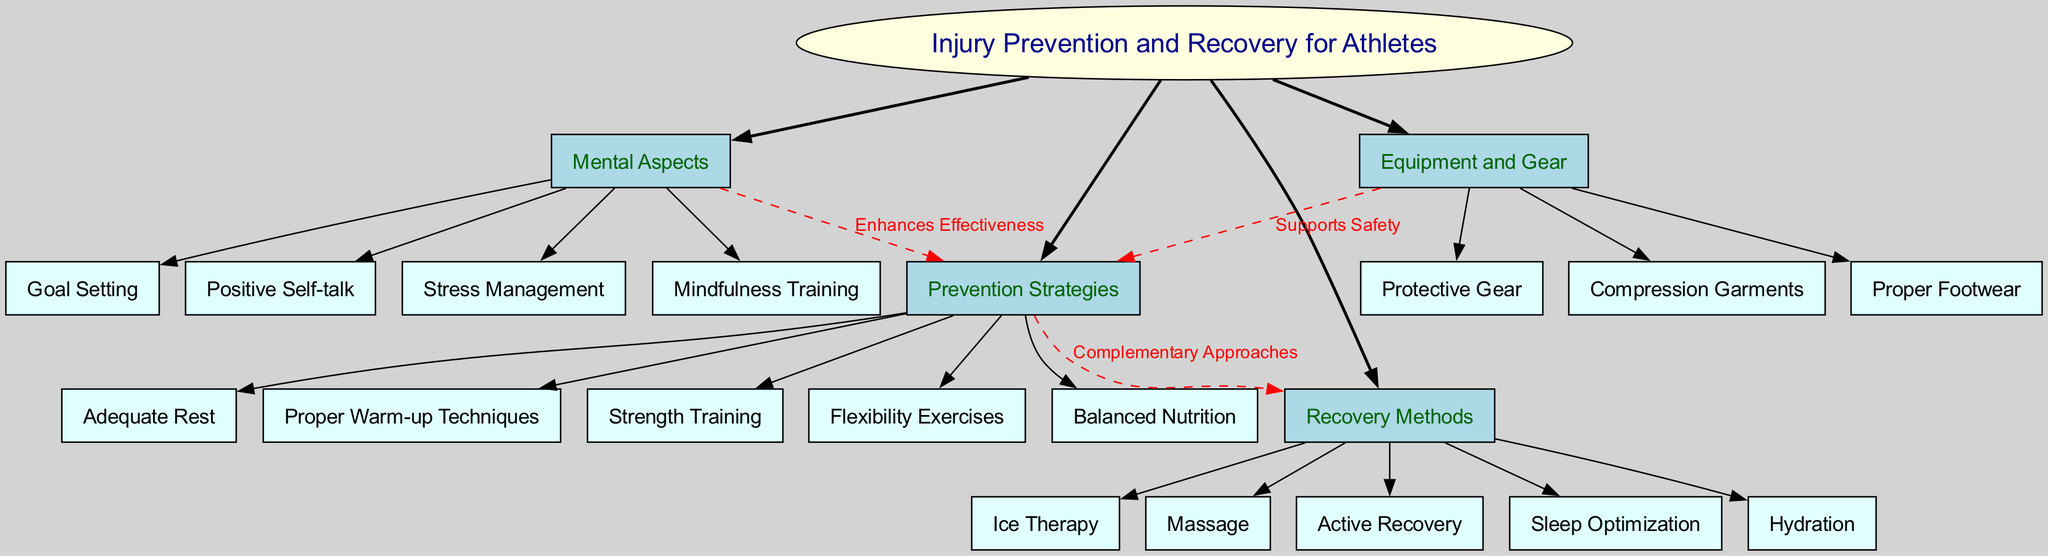What is the central concept of the diagram? The central concept is explicitly labeled in the diagram as "Injury Prevention and Recovery for Athletes," which is the main topic around which all other elements are organized.
Answer: Injury Prevention and Recovery for Athletes How many main branches are there? By reviewing the diagram, I can see that four main branches extend from the central concept: Prevention Strategies, Recovery Methods, Mental Aspects, and Equipment and Gear. That makes a total of 4 branches.
Answer: 4 What is one of the sub-branches under "Recovery Methods"? Looking under the "Recovery Methods" branch, there are several sub-branches listed. One example is "Ice Therapy." This sub-branch provides specific recovery strategies.
Answer: Ice Therapy Which branch has a connection labeled "Enhances Effectiveness"? The connection labeled "Enhances Effectiveness" can be traced from the "Mental Aspects" branch to the "Prevention Strategies" branch in the diagram. This signifies a relationship between mental training and preventive techniques.
Answer: Mental Aspects How many sub-branches does "Equipment and Gear" have? By examining the "Equipment and Gear" branch, there are three sub-branches listed: Proper Footwear, Protective Gear, and Compression Garments, giving a count of 3.
Answer: 3 What are two methods listed under "Recovery Methods"? The "Recovery Methods" branch includes several sub-branches. Two examples are "Massage" and "Active Recovery," both of which are strategies to aid recovery.
Answer: Massage, Active Recovery Which prevention strategy is linked to "Supports Safety"? The label "Supports Safety" connects the "Equipment and Gear" branch to the "Prevention Strategies" branch. This implies that properly selected gear plays a key role in preventing injuries.
Answer: Equipment and Gear Name one mental aspect mentioned in the diagram. Under the "Mental Aspects" branch, one of the sub-branches is "Stress Management," which is an important factor in an athlete's mental well-being.
Answer: Stress Management What is the relationship between "Prevention Strategies" and "Recovery Methods"? The diagram shows a connection between "Prevention Strategies" and "Recovery Methods" labeled as "Complementary Approaches." This indicates that effective prevention strategies are supportive of recovery methods.
Answer: Complementary Approaches 